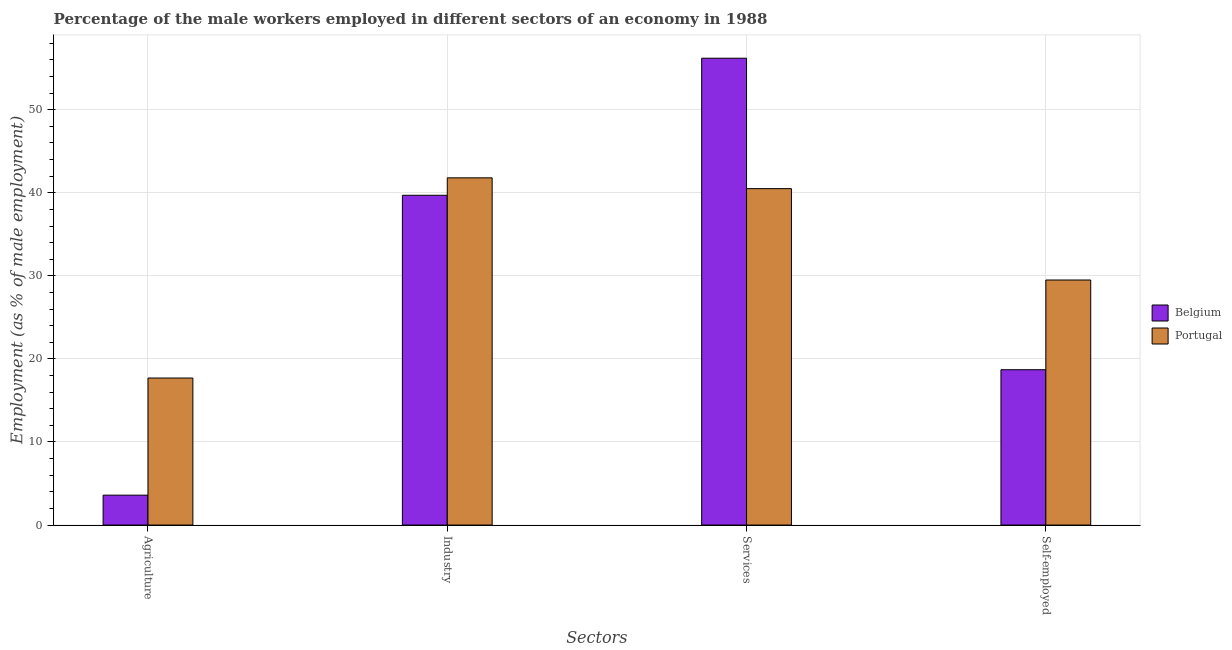Are the number of bars per tick equal to the number of legend labels?
Make the answer very short. Yes. Are the number of bars on each tick of the X-axis equal?
Make the answer very short. Yes. How many bars are there on the 4th tick from the left?
Give a very brief answer. 2. What is the label of the 1st group of bars from the left?
Ensure brevity in your answer.  Agriculture. What is the percentage of male workers in services in Portugal?
Make the answer very short. 40.5. Across all countries, what is the maximum percentage of male workers in services?
Your answer should be very brief. 56.2. Across all countries, what is the minimum percentage of self employed male workers?
Provide a short and direct response. 18.7. In which country was the percentage of male workers in agriculture maximum?
Offer a very short reply. Portugal. In which country was the percentage of male workers in industry minimum?
Give a very brief answer. Belgium. What is the total percentage of male workers in industry in the graph?
Provide a short and direct response. 81.5. What is the difference between the percentage of male workers in industry in Belgium and that in Portugal?
Offer a terse response. -2.1. What is the difference between the percentage of self employed male workers in Belgium and the percentage of male workers in services in Portugal?
Make the answer very short. -21.8. What is the average percentage of male workers in agriculture per country?
Ensure brevity in your answer.  10.65. What is the difference between the percentage of self employed male workers and percentage of male workers in agriculture in Portugal?
Offer a very short reply. 11.8. What is the ratio of the percentage of male workers in industry in Portugal to that in Belgium?
Make the answer very short. 1.05. What is the difference between the highest and the second highest percentage of male workers in agriculture?
Offer a very short reply. 14.1. What is the difference between the highest and the lowest percentage of male workers in services?
Your answer should be compact. 15.7. Is it the case that in every country, the sum of the percentage of self employed male workers and percentage of male workers in agriculture is greater than the sum of percentage of male workers in industry and percentage of male workers in services?
Your answer should be very brief. No. How many bars are there?
Offer a terse response. 8. Are the values on the major ticks of Y-axis written in scientific E-notation?
Your answer should be very brief. No. Does the graph contain grids?
Provide a short and direct response. Yes. How many legend labels are there?
Your answer should be compact. 2. How are the legend labels stacked?
Your answer should be very brief. Vertical. What is the title of the graph?
Provide a short and direct response. Percentage of the male workers employed in different sectors of an economy in 1988. Does "West Bank and Gaza" appear as one of the legend labels in the graph?
Make the answer very short. No. What is the label or title of the X-axis?
Give a very brief answer. Sectors. What is the label or title of the Y-axis?
Offer a very short reply. Employment (as % of male employment). What is the Employment (as % of male employment) of Belgium in Agriculture?
Ensure brevity in your answer.  3.6. What is the Employment (as % of male employment) of Portugal in Agriculture?
Offer a very short reply. 17.7. What is the Employment (as % of male employment) in Belgium in Industry?
Provide a succinct answer. 39.7. What is the Employment (as % of male employment) in Portugal in Industry?
Your answer should be very brief. 41.8. What is the Employment (as % of male employment) of Belgium in Services?
Give a very brief answer. 56.2. What is the Employment (as % of male employment) in Portugal in Services?
Ensure brevity in your answer.  40.5. What is the Employment (as % of male employment) in Belgium in Self-employed?
Provide a succinct answer. 18.7. What is the Employment (as % of male employment) of Portugal in Self-employed?
Offer a terse response. 29.5. Across all Sectors, what is the maximum Employment (as % of male employment) in Belgium?
Keep it short and to the point. 56.2. Across all Sectors, what is the maximum Employment (as % of male employment) of Portugal?
Provide a succinct answer. 41.8. Across all Sectors, what is the minimum Employment (as % of male employment) in Belgium?
Offer a very short reply. 3.6. Across all Sectors, what is the minimum Employment (as % of male employment) of Portugal?
Your answer should be very brief. 17.7. What is the total Employment (as % of male employment) of Belgium in the graph?
Offer a very short reply. 118.2. What is the total Employment (as % of male employment) in Portugal in the graph?
Make the answer very short. 129.5. What is the difference between the Employment (as % of male employment) in Belgium in Agriculture and that in Industry?
Offer a terse response. -36.1. What is the difference between the Employment (as % of male employment) of Portugal in Agriculture and that in Industry?
Offer a very short reply. -24.1. What is the difference between the Employment (as % of male employment) in Belgium in Agriculture and that in Services?
Provide a short and direct response. -52.6. What is the difference between the Employment (as % of male employment) in Portugal in Agriculture and that in Services?
Provide a short and direct response. -22.8. What is the difference between the Employment (as % of male employment) of Belgium in Agriculture and that in Self-employed?
Give a very brief answer. -15.1. What is the difference between the Employment (as % of male employment) in Portugal in Agriculture and that in Self-employed?
Ensure brevity in your answer.  -11.8. What is the difference between the Employment (as % of male employment) of Belgium in Industry and that in Services?
Provide a succinct answer. -16.5. What is the difference between the Employment (as % of male employment) in Portugal in Industry and that in Self-employed?
Your response must be concise. 12.3. What is the difference between the Employment (as % of male employment) in Belgium in Services and that in Self-employed?
Give a very brief answer. 37.5. What is the difference between the Employment (as % of male employment) of Belgium in Agriculture and the Employment (as % of male employment) of Portugal in Industry?
Offer a very short reply. -38.2. What is the difference between the Employment (as % of male employment) in Belgium in Agriculture and the Employment (as % of male employment) in Portugal in Services?
Offer a terse response. -36.9. What is the difference between the Employment (as % of male employment) of Belgium in Agriculture and the Employment (as % of male employment) of Portugal in Self-employed?
Provide a succinct answer. -25.9. What is the difference between the Employment (as % of male employment) in Belgium in Industry and the Employment (as % of male employment) in Portugal in Services?
Your response must be concise. -0.8. What is the difference between the Employment (as % of male employment) of Belgium in Services and the Employment (as % of male employment) of Portugal in Self-employed?
Provide a succinct answer. 26.7. What is the average Employment (as % of male employment) of Belgium per Sectors?
Offer a terse response. 29.55. What is the average Employment (as % of male employment) in Portugal per Sectors?
Your answer should be compact. 32.38. What is the difference between the Employment (as % of male employment) of Belgium and Employment (as % of male employment) of Portugal in Agriculture?
Provide a succinct answer. -14.1. What is the ratio of the Employment (as % of male employment) in Belgium in Agriculture to that in Industry?
Your response must be concise. 0.09. What is the ratio of the Employment (as % of male employment) of Portugal in Agriculture to that in Industry?
Your answer should be very brief. 0.42. What is the ratio of the Employment (as % of male employment) in Belgium in Agriculture to that in Services?
Your answer should be very brief. 0.06. What is the ratio of the Employment (as % of male employment) of Portugal in Agriculture to that in Services?
Keep it short and to the point. 0.44. What is the ratio of the Employment (as % of male employment) in Belgium in Agriculture to that in Self-employed?
Give a very brief answer. 0.19. What is the ratio of the Employment (as % of male employment) in Portugal in Agriculture to that in Self-employed?
Your answer should be very brief. 0.6. What is the ratio of the Employment (as % of male employment) of Belgium in Industry to that in Services?
Give a very brief answer. 0.71. What is the ratio of the Employment (as % of male employment) of Portugal in Industry to that in Services?
Your response must be concise. 1.03. What is the ratio of the Employment (as % of male employment) of Belgium in Industry to that in Self-employed?
Your response must be concise. 2.12. What is the ratio of the Employment (as % of male employment) in Portugal in Industry to that in Self-employed?
Make the answer very short. 1.42. What is the ratio of the Employment (as % of male employment) in Belgium in Services to that in Self-employed?
Offer a very short reply. 3.01. What is the ratio of the Employment (as % of male employment) in Portugal in Services to that in Self-employed?
Your answer should be compact. 1.37. What is the difference between the highest and the second highest Employment (as % of male employment) of Belgium?
Provide a succinct answer. 16.5. What is the difference between the highest and the lowest Employment (as % of male employment) of Belgium?
Provide a succinct answer. 52.6. What is the difference between the highest and the lowest Employment (as % of male employment) of Portugal?
Ensure brevity in your answer.  24.1. 